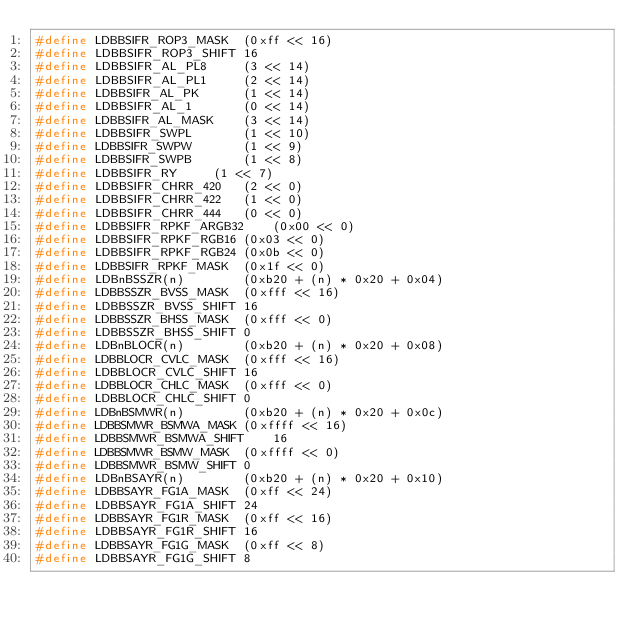<code> <loc_0><loc_0><loc_500><loc_500><_C_>#define LDBBSIFR_ROP3_MASK	(0xff << 16)
#define LDBBSIFR_ROP3_SHIFT	16
#define LDBBSIFR_AL_PL8		(3 << 14)
#define LDBBSIFR_AL_PL1		(2 << 14)
#define LDBBSIFR_AL_PK		(1 << 14)
#define LDBBSIFR_AL_1		(0 << 14)
#define LDBBSIFR_AL_MASK	(3 << 14)
#define LDBBSIFR_SWPL		(1 << 10)
#define LDBBSIFR_SWPW		(1 << 9)
#define LDBBSIFR_SWPB		(1 << 8)
#define LDBBSIFR_RY		(1 << 7)
#define LDBBSIFR_CHRR_420	(2 << 0)
#define LDBBSIFR_CHRR_422	(1 << 0)
#define LDBBSIFR_CHRR_444	(0 << 0)
#define LDBBSIFR_RPKF_ARGB32	(0x00 << 0)
#define LDBBSIFR_RPKF_RGB16	(0x03 << 0)
#define LDBBSIFR_RPKF_RGB24	(0x0b << 0)
#define LDBBSIFR_RPKF_MASK	(0x1f << 0)
#define LDBnBSSZR(n)		(0xb20 + (n) * 0x20 + 0x04)
#define LDBBSSZR_BVSS_MASK	(0xfff << 16)
#define LDBBSSZR_BVSS_SHIFT	16
#define LDBBSSZR_BHSS_MASK	(0xfff << 0)
#define LDBBSSZR_BHSS_SHIFT	0
#define LDBnBLOCR(n)		(0xb20 + (n) * 0x20 + 0x08)
#define LDBBLOCR_CVLC_MASK	(0xfff << 16)
#define LDBBLOCR_CVLC_SHIFT	16
#define LDBBLOCR_CHLC_MASK	(0xfff << 0)
#define LDBBLOCR_CHLC_SHIFT	0
#define LDBnBSMWR(n)		(0xb20 + (n) * 0x20 + 0x0c)
#define LDBBSMWR_BSMWA_MASK	(0xffff << 16)
#define LDBBSMWR_BSMWA_SHIFT	16
#define LDBBSMWR_BSMW_MASK	(0xffff << 0)
#define LDBBSMWR_BSMW_SHIFT	0
#define LDBnBSAYR(n)		(0xb20 + (n) * 0x20 + 0x10)
#define LDBBSAYR_FG1A_MASK	(0xff << 24)
#define LDBBSAYR_FG1A_SHIFT	24
#define LDBBSAYR_FG1R_MASK	(0xff << 16)
#define LDBBSAYR_FG1R_SHIFT	16
#define LDBBSAYR_FG1G_MASK	(0xff << 8)
#define LDBBSAYR_FG1G_SHIFT	8</code> 